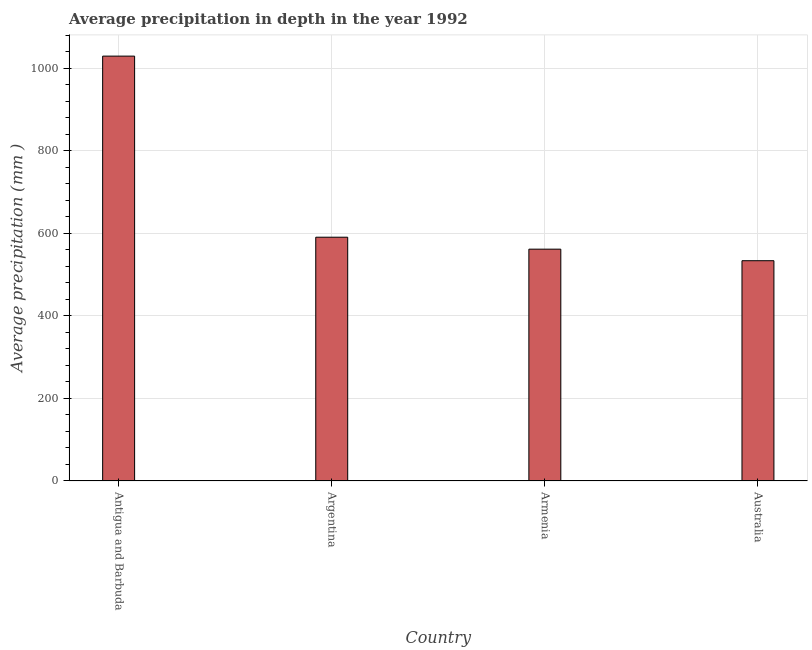Does the graph contain any zero values?
Provide a succinct answer. No. Does the graph contain grids?
Keep it short and to the point. Yes. What is the title of the graph?
Provide a succinct answer. Average precipitation in depth in the year 1992. What is the label or title of the X-axis?
Offer a terse response. Country. What is the label or title of the Y-axis?
Your answer should be compact. Average precipitation (mm ). What is the average precipitation in depth in Argentina?
Give a very brief answer. 591. Across all countries, what is the maximum average precipitation in depth?
Provide a succinct answer. 1030. Across all countries, what is the minimum average precipitation in depth?
Ensure brevity in your answer.  534. In which country was the average precipitation in depth maximum?
Offer a terse response. Antigua and Barbuda. What is the sum of the average precipitation in depth?
Offer a very short reply. 2717. What is the difference between the average precipitation in depth in Antigua and Barbuda and Argentina?
Offer a terse response. 439. What is the average average precipitation in depth per country?
Provide a short and direct response. 679. What is the median average precipitation in depth?
Your response must be concise. 576.5. What is the ratio of the average precipitation in depth in Armenia to that in Australia?
Keep it short and to the point. 1.05. What is the difference between the highest and the second highest average precipitation in depth?
Your response must be concise. 439. What is the difference between the highest and the lowest average precipitation in depth?
Give a very brief answer. 496. In how many countries, is the average precipitation in depth greater than the average average precipitation in depth taken over all countries?
Offer a terse response. 1. How many bars are there?
Make the answer very short. 4. How many countries are there in the graph?
Keep it short and to the point. 4. What is the difference between two consecutive major ticks on the Y-axis?
Keep it short and to the point. 200. Are the values on the major ticks of Y-axis written in scientific E-notation?
Offer a terse response. No. What is the Average precipitation (mm ) in Antigua and Barbuda?
Your answer should be compact. 1030. What is the Average precipitation (mm ) of Argentina?
Provide a short and direct response. 591. What is the Average precipitation (mm ) in Armenia?
Your answer should be compact. 562. What is the Average precipitation (mm ) of Australia?
Provide a succinct answer. 534. What is the difference between the Average precipitation (mm ) in Antigua and Barbuda and Argentina?
Your response must be concise. 439. What is the difference between the Average precipitation (mm ) in Antigua and Barbuda and Armenia?
Make the answer very short. 468. What is the difference between the Average precipitation (mm ) in Antigua and Barbuda and Australia?
Your response must be concise. 496. What is the ratio of the Average precipitation (mm ) in Antigua and Barbuda to that in Argentina?
Give a very brief answer. 1.74. What is the ratio of the Average precipitation (mm ) in Antigua and Barbuda to that in Armenia?
Ensure brevity in your answer.  1.83. What is the ratio of the Average precipitation (mm ) in Antigua and Barbuda to that in Australia?
Your answer should be very brief. 1.93. What is the ratio of the Average precipitation (mm ) in Argentina to that in Armenia?
Provide a short and direct response. 1.05. What is the ratio of the Average precipitation (mm ) in Argentina to that in Australia?
Offer a terse response. 1.11. What is the ratio of the Average precipitation (mm ) in Armenia to that in Australia?
Make the answer very short. 1.05. 